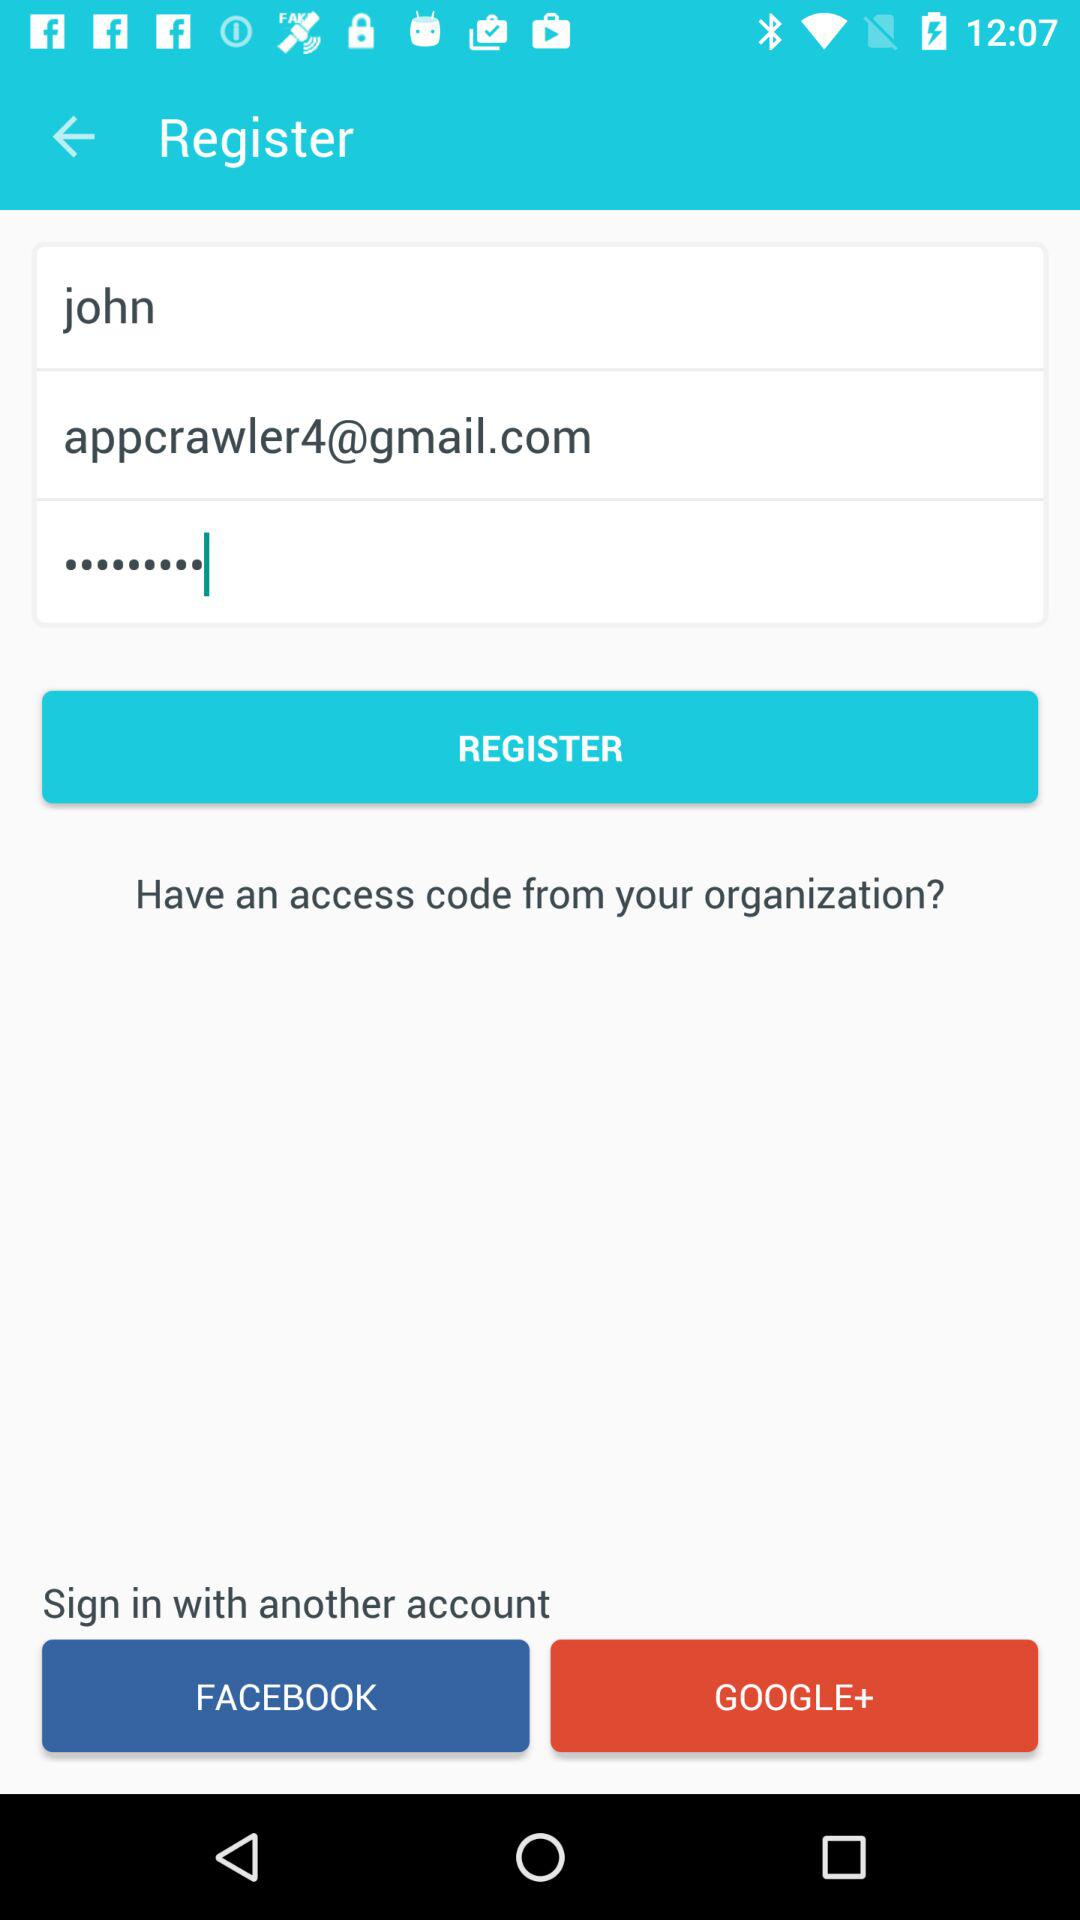Through which application can the user sign in? The user can sign in through "FACEBOOK" and "GOOGLE+". 